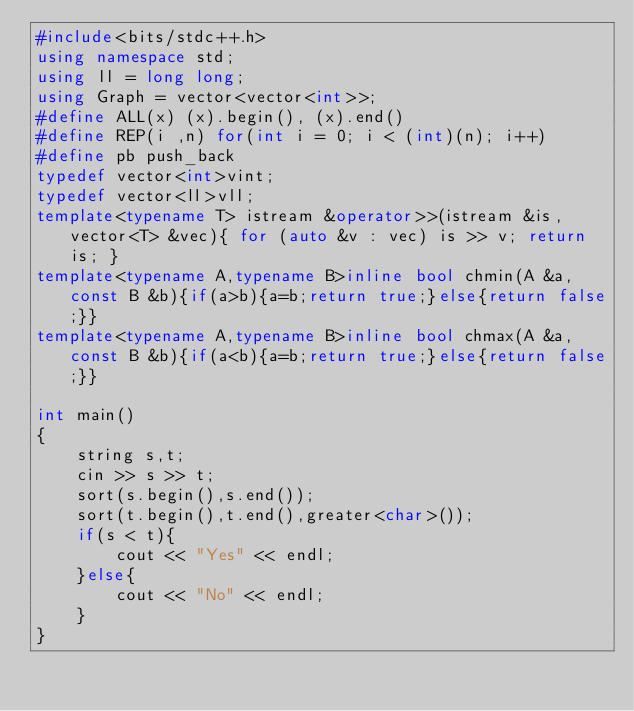<code> <loc_0><loc_0><loc_500><loc_500><_C++_>#include<bits/stdc++.h>
using namespace std;
using ll = long long;
using Graph = vector<vector<int>>;
#define ALL(x) (x).begin(), (x).end()
#define REP(i ,n) for(int i = 0; i < (int)(n); i++)
#define pb push_back
typedef vector<int>vint;
typedef vector<ll>vll;
template<typename T> istream &operator>>(istream &is, vector<T> &vec){ for (auto &v : vec) is >> v; return is; }
template<typename A,typename B>inline bool chmin(A &a,const B &b){if(a>b){a=b;return true;}else{return false;}}
template<typename A,typename B>inline bool chmax(A &a,const B &b){if(a<b){a=b;return true;}else{return false;}}

int main()
{
    string s,t;
    cin >> s >> t;
    sort(s.begin(),s.end());
    sort(t.begin(),t.end(),greater<char>());
    if(s < t){
        cout << "Yes" << endl;
    }else{
        cout << "No" << endl;
    }
}</code> 